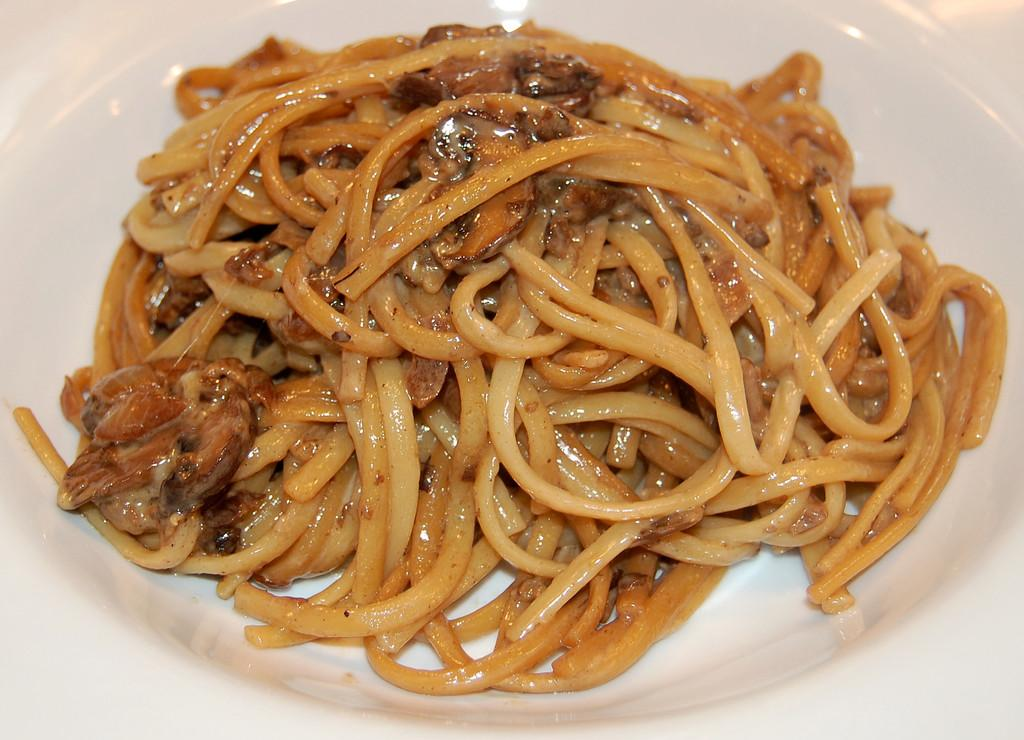What is the color of the main object in the image? The main object in the image is white in color. What can be inferred about the food in the image based on the provided fact? The food in the image is in brown color. What type of toothpaste is visible in the image? There is no toothpaste present in the image. Can you describe the alley in the image? There is no alley present in the image. 